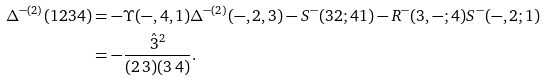<formula> <loc_0><loc_0><loc_500><loc_500>\Delta ^ { - ( 2 ) } ( 1 2 3 4 ) & = - \Upsilon ( - , 4 , 1 ) \Delta ^ { - ( 2 ) } ( - , 2 , 3 ) - S ^ { - } ( 3 2 ; 4 1 ) - R ^ { - } ( 3 , - ; 4 ) S ^ { - } ( - , 2 ; 1 ) \\ & = - \frac { \hat { 3 } ^ { 2 } } { ( 2 \, 3 ) ( 3 \, 4 ) } .</formula> 